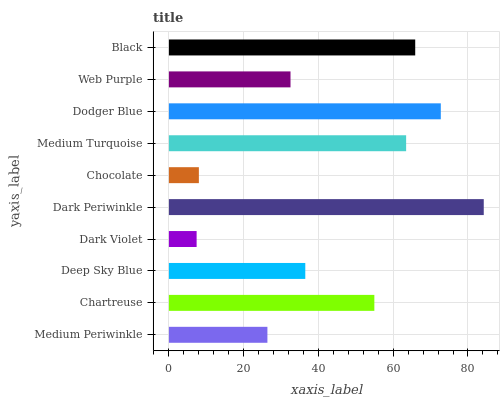Is Dark Violet the minimum?
Answer yes or no. Yes. Is Dark Periwinkle the maximum?
Answer yes or no. Yes. Is Chartreuse the minimum?
Answer yes or no. No. Is Chartreuse the maximum?
Answer yes or no. No. Is Chartreuse greater than Medium Periwinkle?
Answer yes or no. Yes. Is Medium Periwinkle less than Chartreuse?
Answer yes or no. Yes. Is Medium Periwinkle greater than Chartreuse?
Answer yes or no. No. Is Chartreuse less than Medium Periwinkle?
Answer yes or no. No. Is Chartreuse the high median?
Answer yes or no. Yes. Is Deep Sky Blue the low median?
Answer yes or no. Yes. Is Web Purple the high median?
Answer yes or no. No. Is Black the low median?
Answer yes or no. No. 